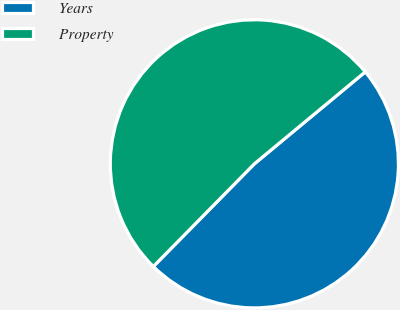Convert chart to OTSL. <chart><loc_0><loc_0><loc_500><loc_500><pie_chart><fcel>Years<fcel>Property<nl><fcel>48.39%<fcel>51.61%<nl></chart> 